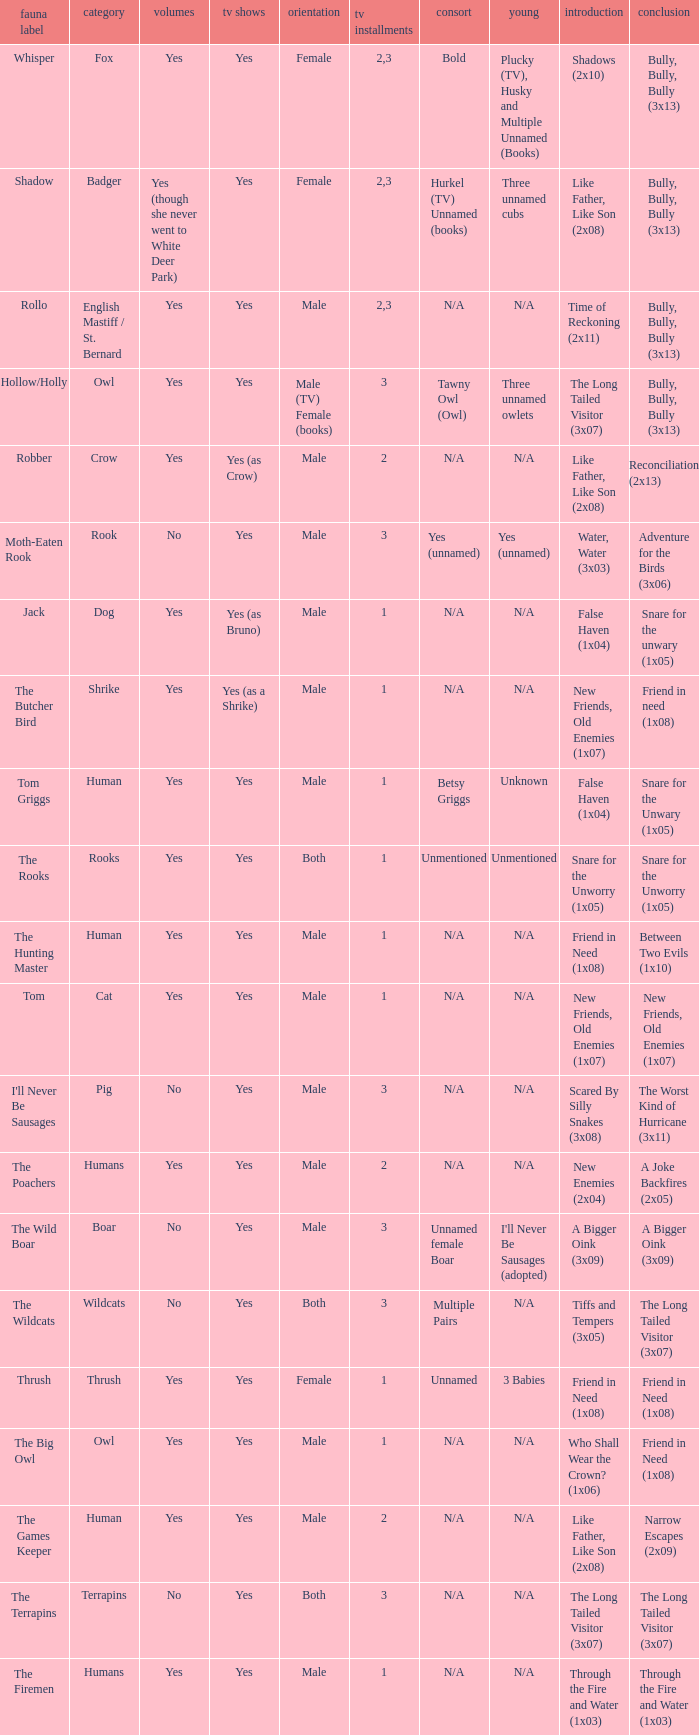What is the smallest season for a tv series with a yes and human was the species? 1.0. 